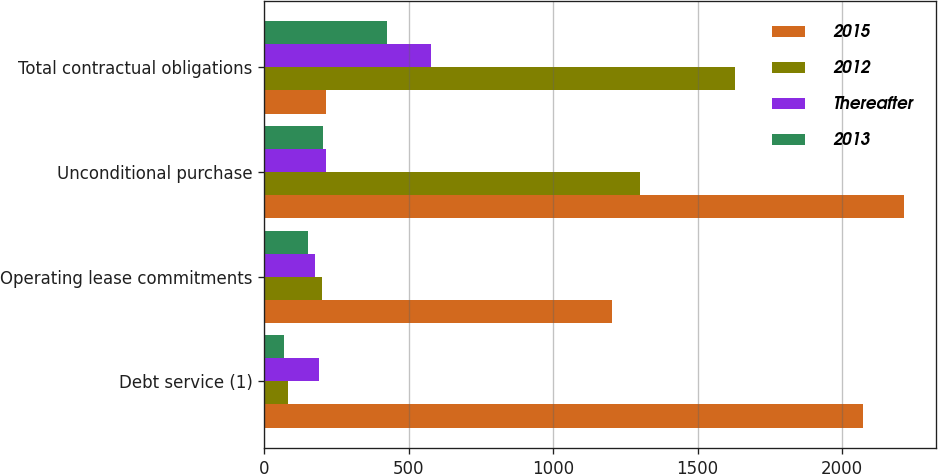<chart> <loc_0><loc_0><loc_500><loc_500><stacked_bar_chart><ecel><fcel>Debt service (1)<fcel>Operating lease commitments<fcel>Unconditional purchase<fcel>Total contractual obligations<nl><fcel>2015<fcel>2072.6<fcel>1203.3<fcel>2212.9<fcel>214.6<nl><fcel>2012<fcel>84.1<fcel>200.2<fcel>1302.3<fcel>1627.9<nl><fcel>Thereafter<fcel>188.7<fcel>175.7<fcel>214.6<fcel>579<nl><fcel>2013<fcel>67.2<fcel>152.3<fcel>204.1<fcel>423.6<nl></chart> 